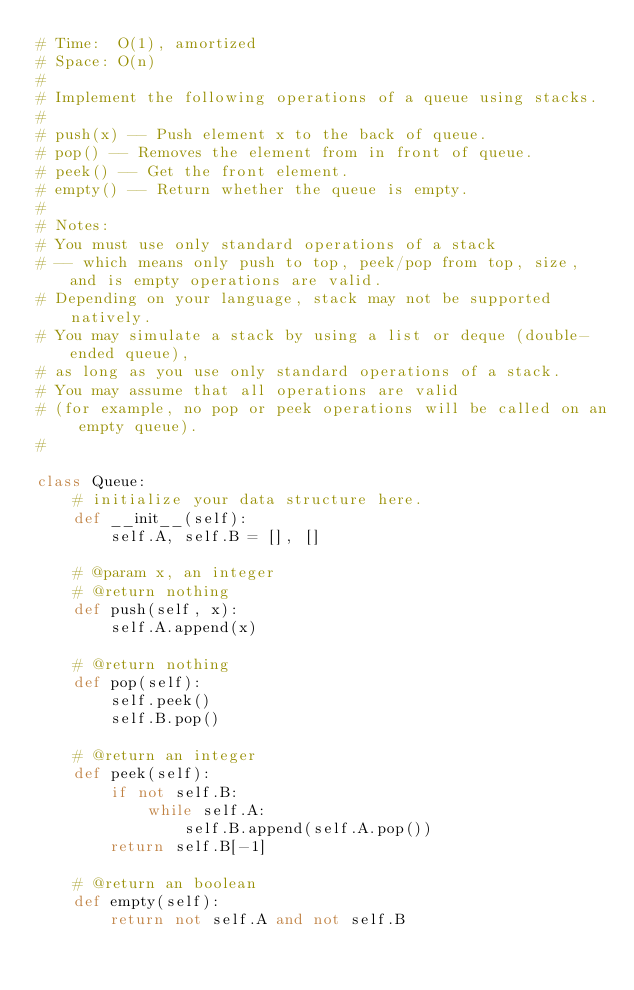<code> <loc_0><loc_0><loc_500><loc_500><_Python_># Time:  O(1), amortized
# Space: O(n)
#
# Implement the following operations of a queue using stacks.
#
# push(x) -- Push element x to the back of queue.
# pop() -- Removes the element from in front of queue.
# peek() -- Get the front element.
# empty() -- Return whether the queue is empty.
#
# Notes:
# You must use only standard operations of a stack
# -- which means only push to top, peek/pop from top, size, and is empty operations are valid.
# Depending on your language, stack may not be supported natively.
# You may simulate a stack by using a list or deque (double-ended queue),
# as long as you use only standard operations of a stack.
# You may assume that all operations are valid
# (for example, no pop or peek operations will be called on an empty queue).
#

class Queue:
    # initialize your data structure here.
    def __init__(self):
        self.A, self.B = [], []

    # @param x, an integer
    # @return nothing
    def push(self, x):
        self.A.append(x)

    # @return nothing
    def pop(self):
        self.peek()
        self.B.pop()
        
    # @return an integer
    def peek(self):
        if not self.B:
            while self.A:
                self.B.append(self.A.pop())
        return self.B[-1]
        
    # @return an boolean
    def empty(self):
        return not self.A and not self.B
</code> 